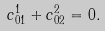<formula> <loc_0><loc_0><loc_500><loc_500>c _ { 0 1 } ^ { 1 } + c _ { 0 2 } ^ { 2 } = 0 .</formula> 